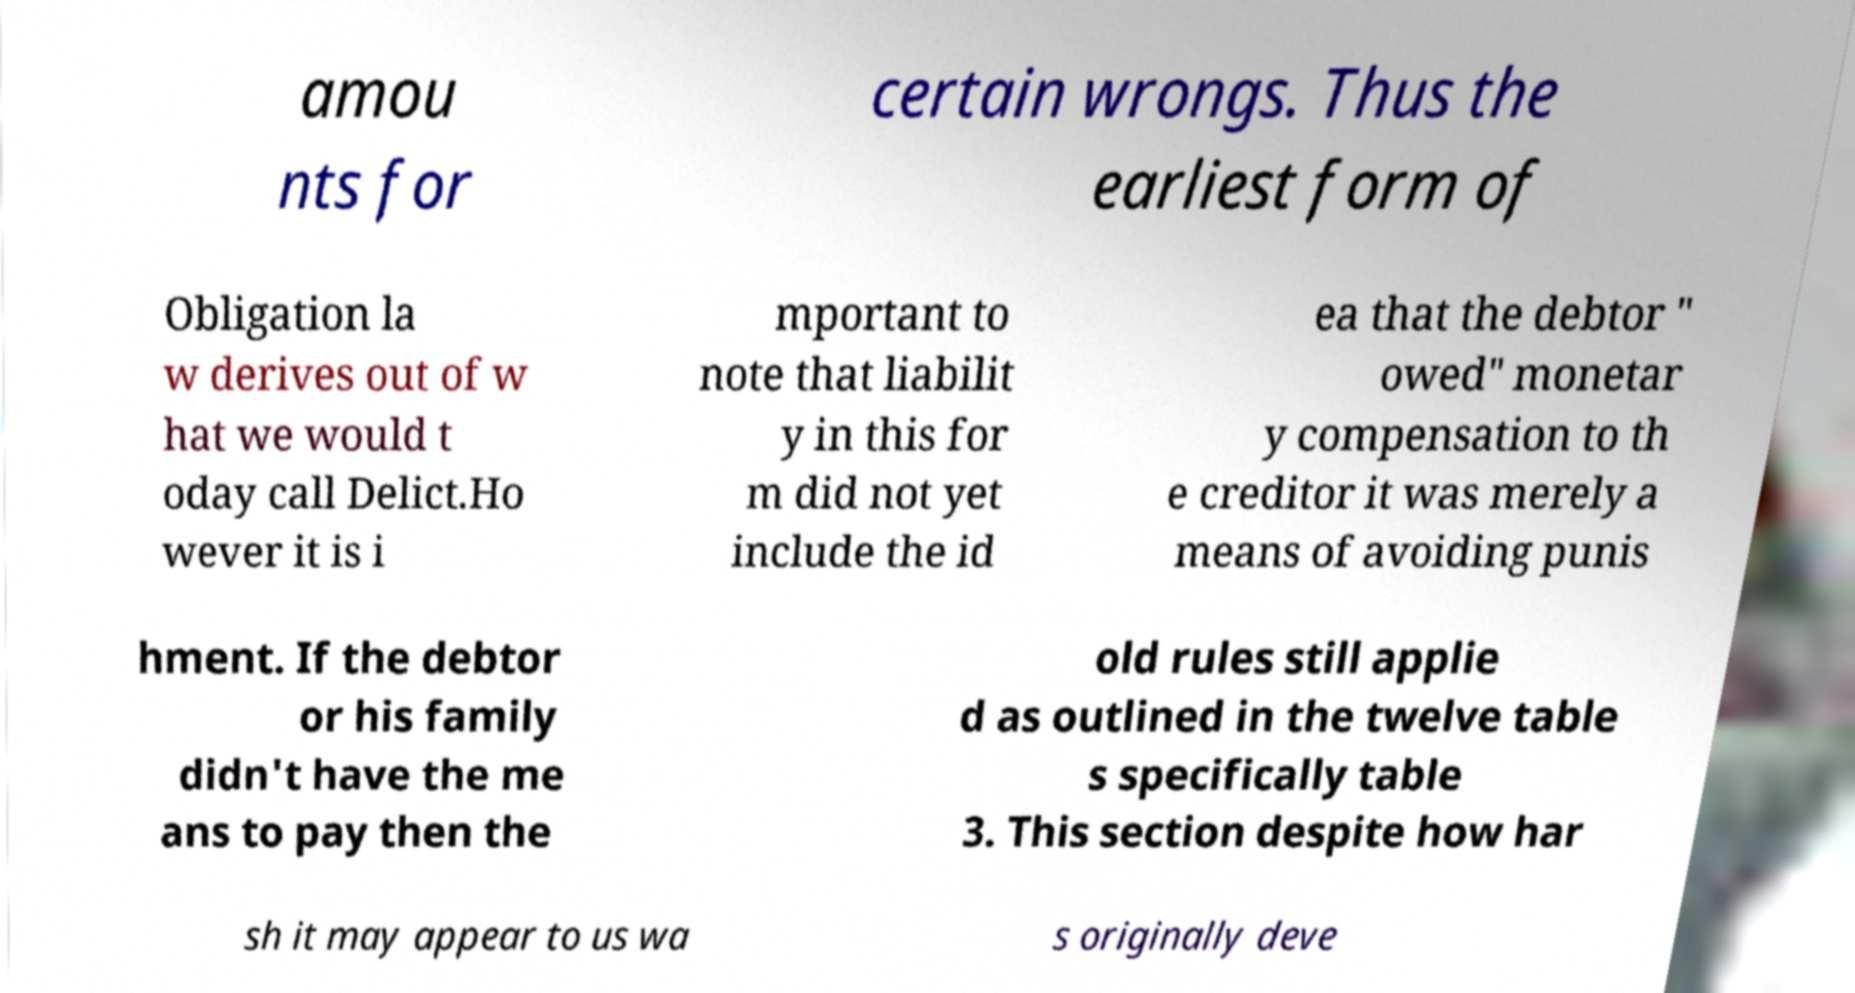Please read and relay the text visible in this image. What does it say? amou nts for certain wrongs. Thus the earliest form of Obligation la w derives out of w hat we would t oday call Delict.Ho wever it is i mportant to note that liabilit y in this for m did not yet include the id ea that the debtor " owed" monetar y compensation to th e creditor it was merely a means of avoiding punis hment. If the debtor or his family didn't have the me ans to pay then the old rules still applie d as outlined in the twelve table s specifically table 3. This section despite how har sh it may appear to us wa s originally deve 